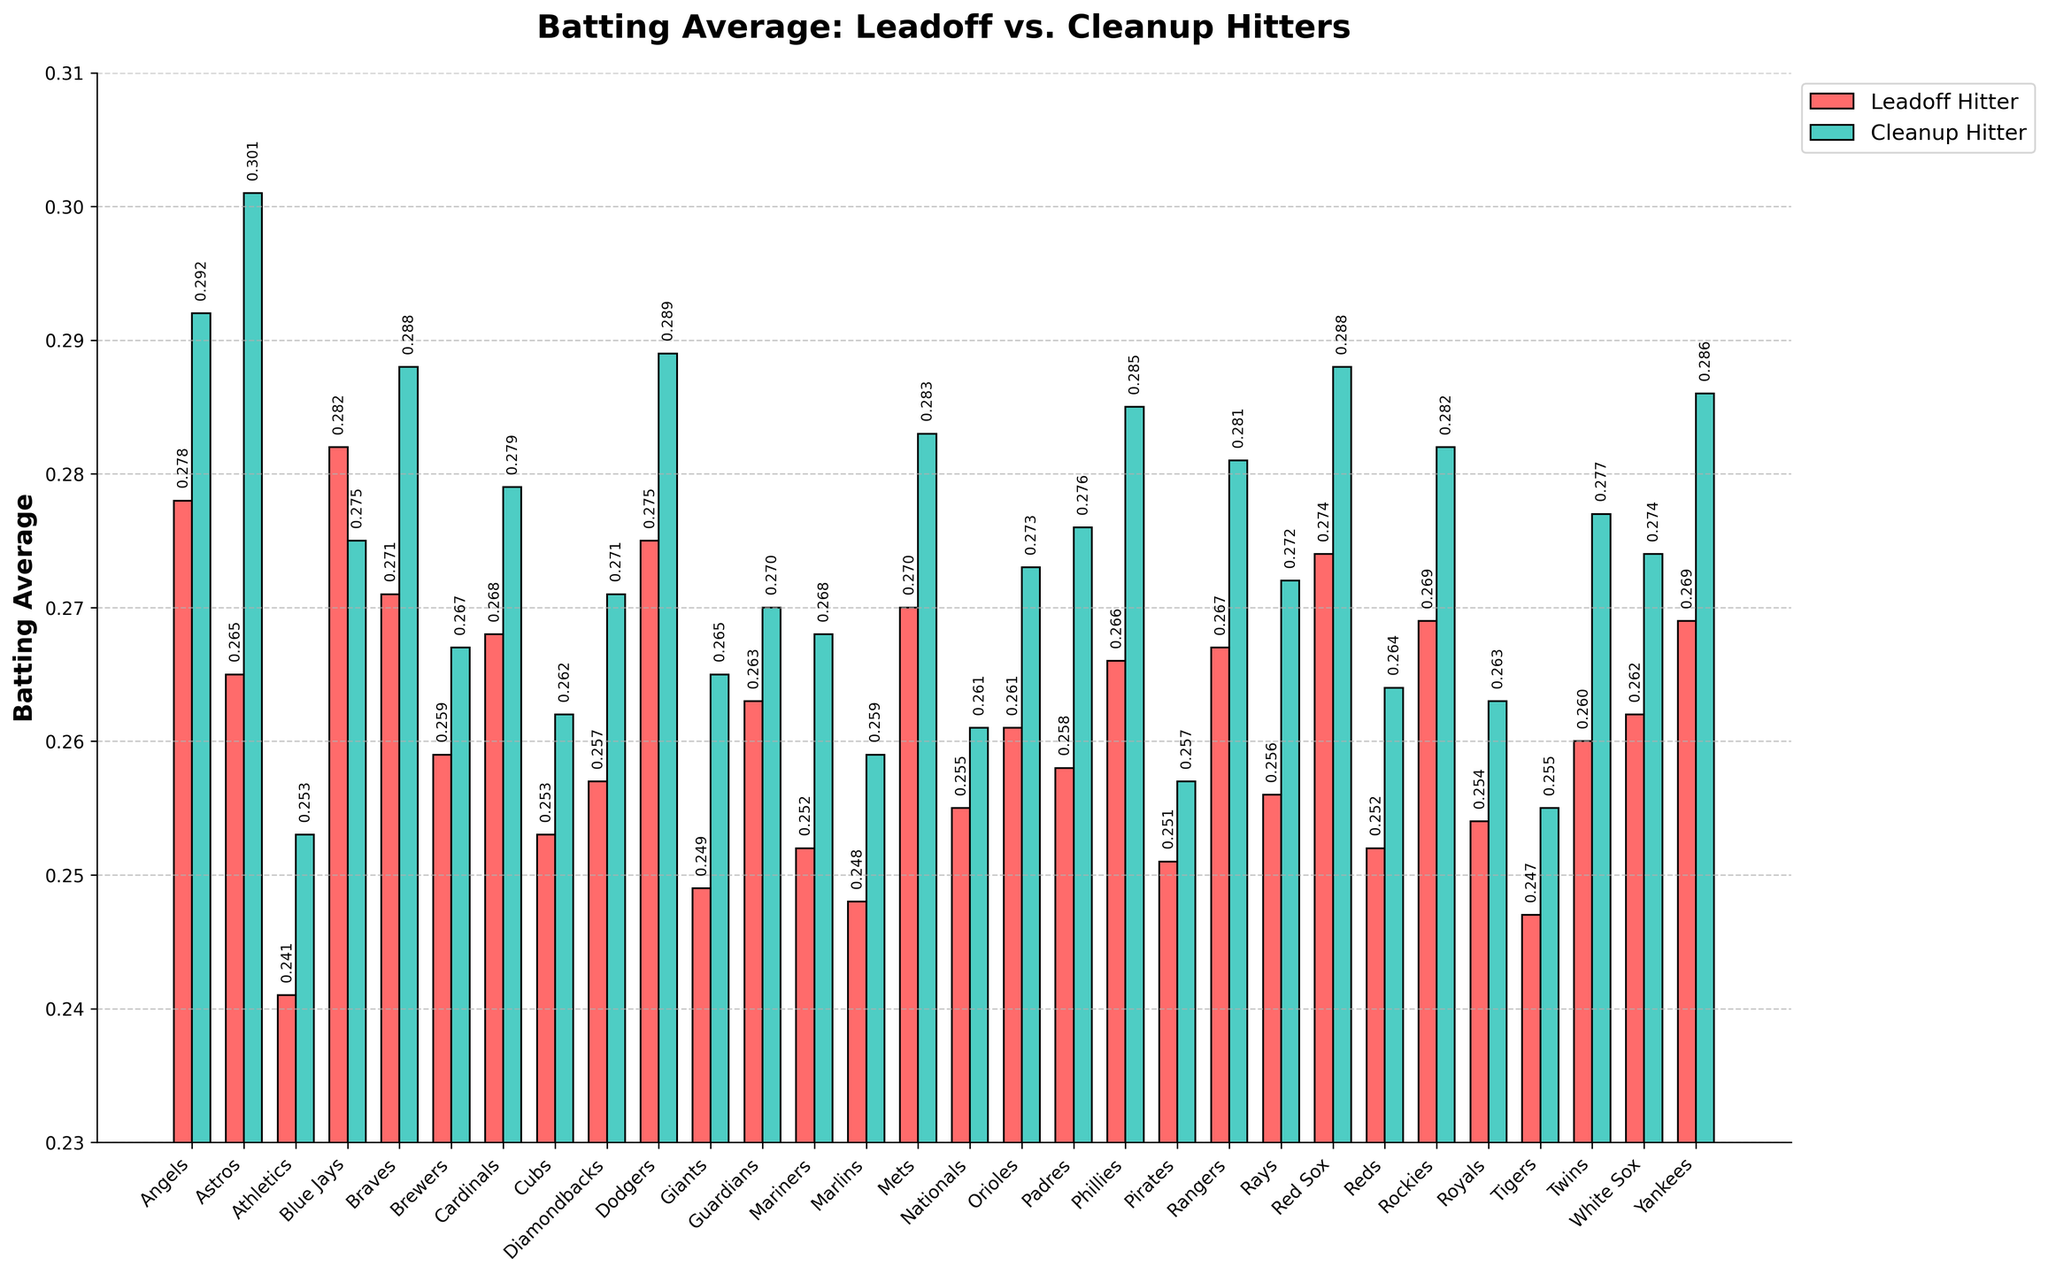what's the average batting average of the cleanup hitters for all teams? To find the average batting average of the cleanup hitters, sum all the batting averages of the cleanup hitters and then divide by the number of teams (30). \( \frac{0.292 + 0.301 + 0.253 + 0.275 + 0.288 + 0.267 + 0.279 + 0.262 + 0.271 + 0.289 + 0.265 + 0.270 + 0.268 + 0.259 + 0.283 + 0.261 + 0.273 + 0.276 + 0.285 + 0.257 + 0.281 + 0.272 + 0.288 + 0.264 + 0.282 + 0.263 + 0.255 + 0.277 + 0.274 + 0.286 }{30} = 0.2732 \)
Answer: 0.273 Does any team have a higher leadoff hitter batting average than its cleanup hitter batting average? If so, which one? Compare each team's leadoff hitter's batting average with its cleanup hitter's batting average. The Blue Jays have a higher leadoff hitter average (0.282) compared to their cleanup hitter average (0.275).
Answer: Blue Jays Which team has the highest leadoff hitter batting average? Look for the team with the highest bar corresponding to the leadoff hitters. The Blue Jays have the highest leadoff hitter batting average (0.282).
Answer: Blue Jays Which team's cleanup hitters have the highest batting average? Find the team with the tallest bar representing cleanup hitters. The Astros have the highest batting average for cleanup hitters (0.301).
Answer: Astros What is the median batting average for leadoff hitters? To determine the median, list the leadoff batting averages in numerical order and find the middle value. The ordered values are [0.241, 0.247, 0.248, 0.249, 0.251, 0.252, 0.252, 0.253, 0.254, 0.255, 0.256, 0.257, 0.258, 0.259, 0.260, 0.261, 0.262, 0.263, 0.265, 0.266, 0.267, 0.268, 0.269, 0.269, 0.270, 0.271, 0.274, 0.275, 0.278, 0.282]. The median value (the average of the 15th and 16th values) is \( \frac{0.260 + 0.261}{2} = 0.2605 \).
Answer: 0.2605 How much higher is the batting average of the Dodgers' cleanup hitter compared to the Diamondbacks' cleanup hitter? Subtract the batting average of the Diamondbacks' cleanup hitter from that of the Dodgers' cleanup hitter: 0.289 - 0.271 = 0.018
Answer: 0.018 